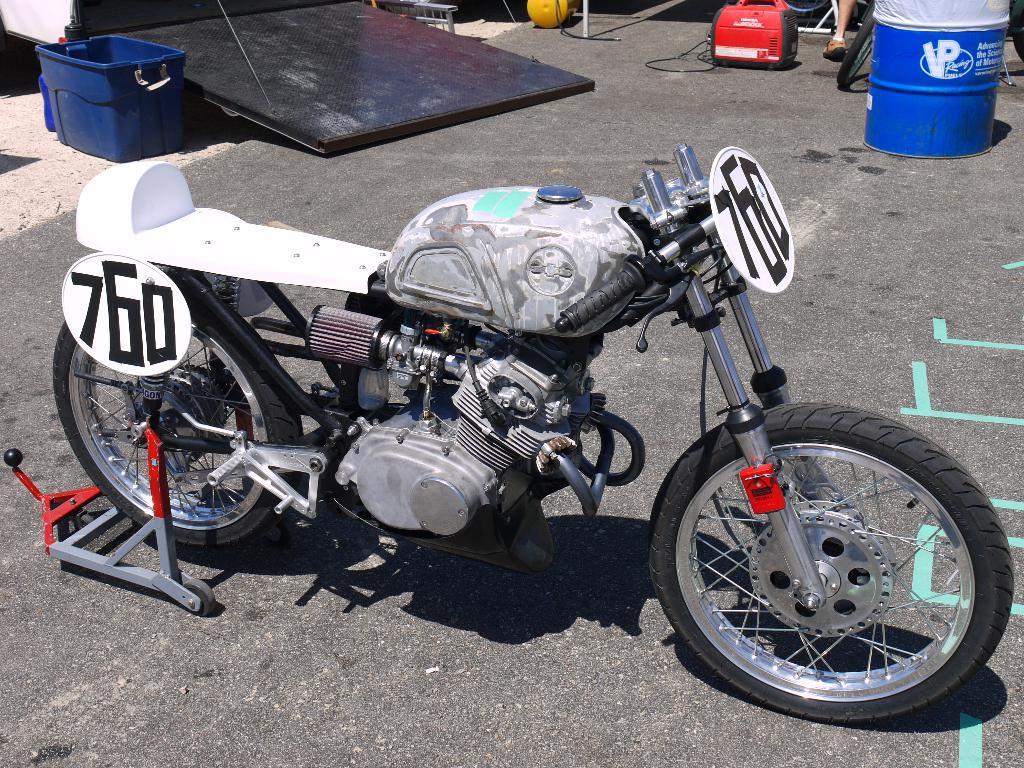How would you summarize this image in a sentence or two? There is a bike on the ground as we can see in the middle of this image, and there are some objects kept on the ground is at the top of this image. 